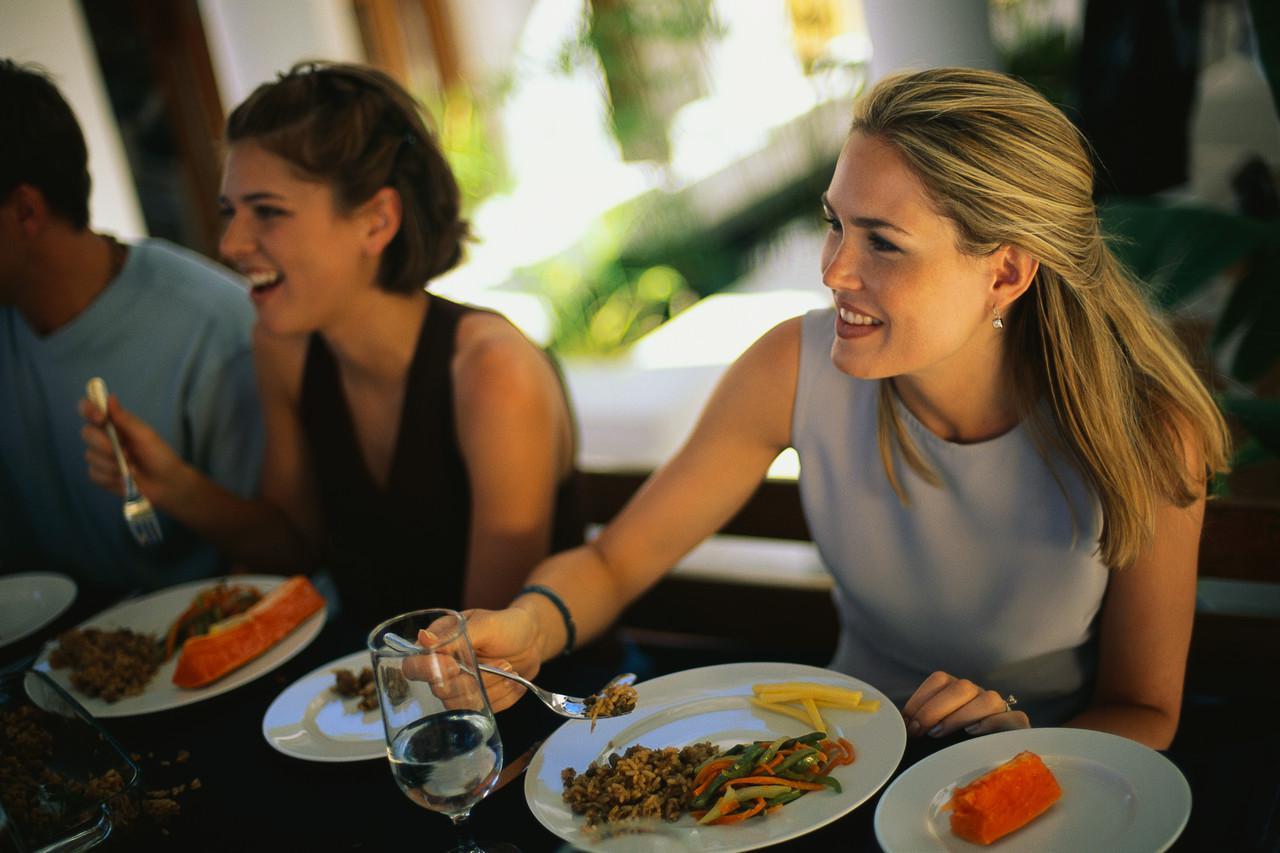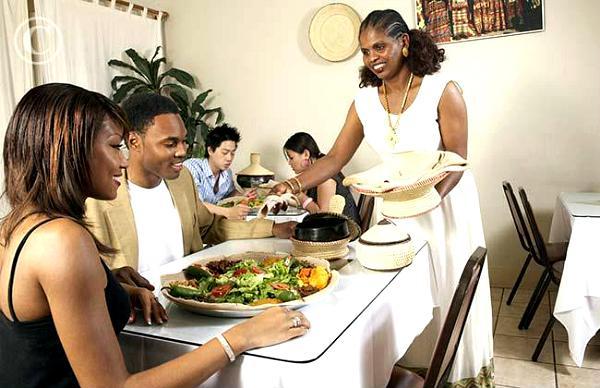The first image is the image on the left, the second image is the image on the right. Examine the images to the left and right. Is the description "The woman on the right at a table is lifting a forkful of food above a white plate, in the lefthand image." accurate? Answer yes or no. Yes. The first image is the image on the left, the second image is the image on the right. Evaluate the accuracy of this statement regarding the images: "The people around the tables are looking at each other and not the camera.". Is it true? Answer yes or no. Yes. 